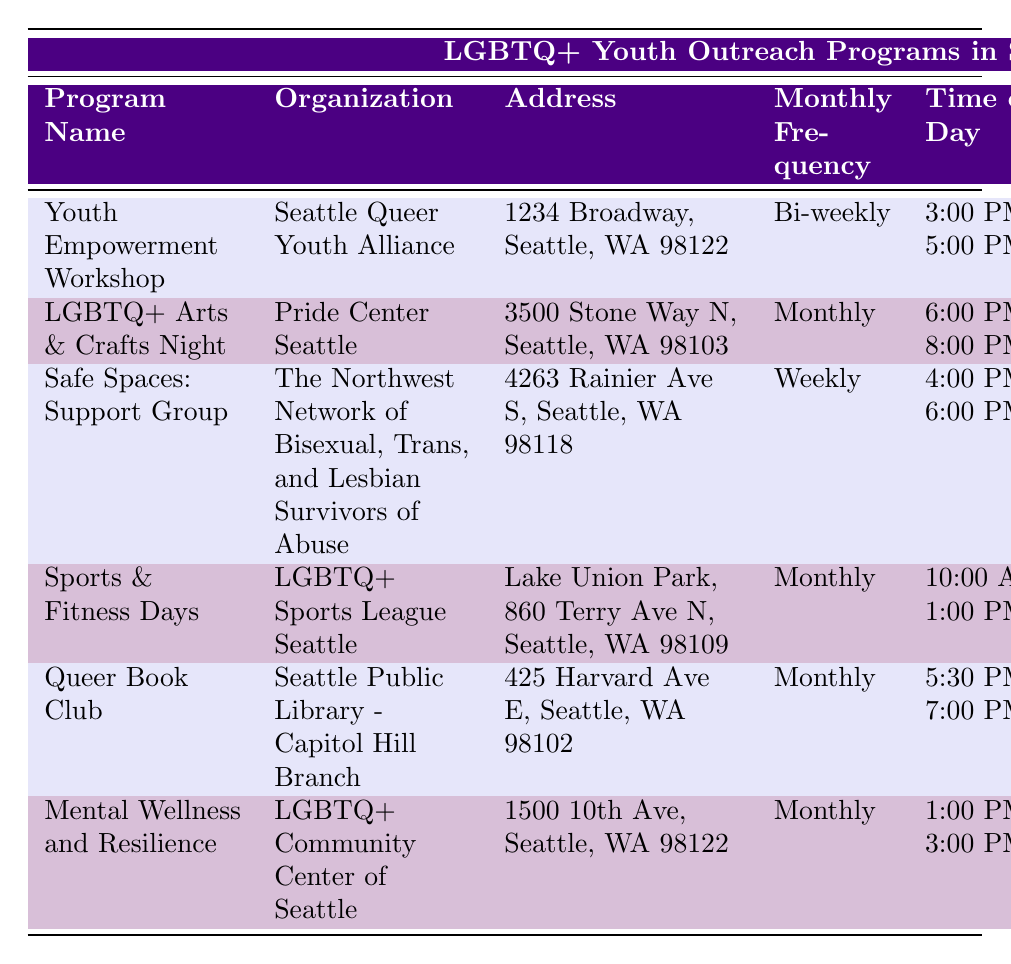What is the location of the "LGBTQ+ Arts & Crafts Night"? From the table, we can see that the location for the "LGBTQ+ Arts & Crafts Night" is listed under the "Location" column. It is found at "3500 Stone Way N, Seattle, WA 98103".
Answer: 3500 Stone Way N, Seattle, WA 98103 Which program targets the age group of 14-21 years? By checking the "Target Age Group" column, we can see that the "Mental Wellness and Resilience" program has the age group listed as "14-21 years".
Answer: Mental Wellness and Resilience How many programs are offered monthly? We can count the programs listed with the "Frequency" as "Monthly". They are: "LGBTQ+ Arts & Crafts Night", "Sports & Fitness Days", "Queer Book Club", and "Mental Wellness and Resilience". This gives us a total of 4 programs.
Answer: 4 Does the "Safe Spaces: Support Group" occur monthly? Looking at the "Frequency" column, "Safe Spaces: Support Group" is labeled as "Weekly" and not "Monthly". Therefore, the answer is no.
Answer: No What is the average time range of the programs that are held monthly? First, we identify the monthly programs: "LGBTQ+ Arts & Crafts Night", "Sports & Fitness Days", "Queer Book Club", and "Mental Wellness and Resilience". The times are "6:00 PM - 8:00 PM", "10:00 AM - 1:00 PM", "5:30 PM - 7:00 PM", and "1:00 PM - 3:00 PM". If we convert these times into 24-hour format and calculate the midpoints (7:00 PM, 11:30 AM, 6:15 PM, and 2:00 PM), we average them, which gives us approximately 4:15 PM.
Answer: 4:15 PM Which organization runs the "Youth Empowerment Workshop"? The table shows a connection between the "Program Name" "Youth Empowerment Workshop" and the "Organization" column, indicating it is run by the "Seattle Queer Youth Alliance".
Answer: Seattle Queer Youth Alliance How many age groups fall between 12 and 22 years old? The relevant age groups to consider are "12-20 years", "14-22 years", and "14-21 years". Therefore, the age ranges collectively cover ages 12 to 22. However, since they overlap, we find a total of 3 unique groups within that range: 12-20 (includes ages 12-20), 14-21 (includes ages 14-21), and 14-22 (includes ages 14-22).
Answer: 3 What is the contact information for the "Queer Book Club"? The "Contact Info" column states the email as "capitolhill@seattle.gov" and the phone number as "(206) 555-0202" for the "Queer Book Club".
Answer: capitolhill@seattle.gov / (206) 555-0202 Which program occurs at Lake Union Park? The address in the "Location" column for the program occurring at Lake Union Park is found next to "Sports & Fitness Days".
Answer: Sports & Fitness Days Are there any programs specifically for those 25 years old or older? Reviewing the "Target Age Group" column shows that all programs target individuals under the age of 25. Therefore, there are no programs for those 25 or older.
Answer: No 